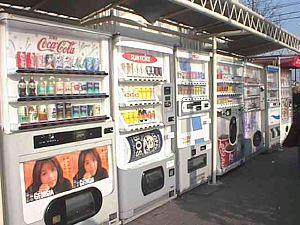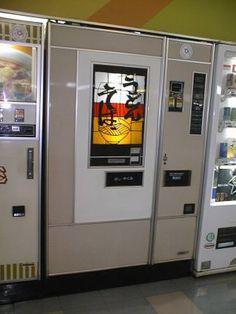The first image is the image on the left, the second image is the image on the right. Assess this claim about the two images: "The left image contains a single vending machine.". Correct or not? Answer yes or no. No. 